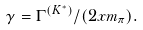Convert formula to latex. <formula><loc_0><loc_0><loc_500><loc_500>\gamma = \Gamma ^ { ( K ^ { * } ) } / ( 2 x m _ { \pi } ) .</formula> 